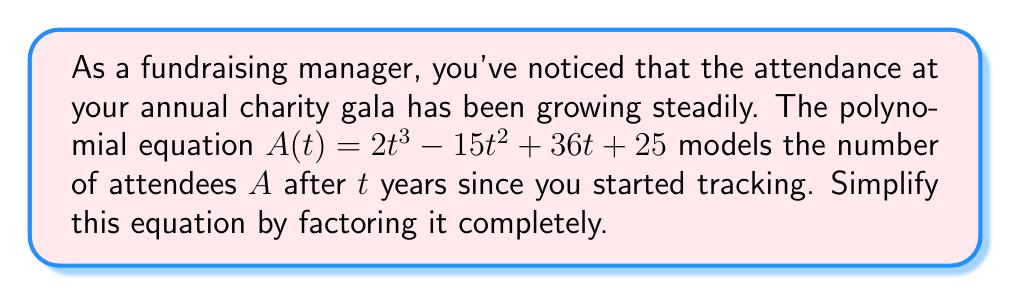Can you answer this question? Let's approach this step-by-step:

1) First, we need to identify if there are any common factors. In this case, there are no common factors for all terms.

2) Next, we'll check if this is a perfect cubic equation. It's not, so we'll proceed with factoring.

3) We can use the rational root theorem to find potential roots. The factors of the constant term (25) are: ±1, ±5, ±25.

4) Testing these values, we find that -1 is a root of the equation.

5) We can factor out $(t+1)$:

   $A(t) = (t+1)(2t^2 - 17t + 25)$

6) Now we need to factor the quadratic term $2t^2 - 17t + 25$. We can use the quadratic formula or factoring by grouping.

7) Using the quadratic formula:
   $t = \frac{17 \pm \sqrt{17^2 - 4(2)(25)}}{2(2)} = \frac{17 \pm \sqrt{289 - 200}}{4} = \frac{17 \pm \sqrt{89}}{4}$

8) This doesn't give us nice rational roots, so let's try factoring by grouping:

   $2t^2 - 17t + 25 = (2t - 5)(t - 5)$

9) Therefore, our final factored equation is:

   $A(t) = (t+1)(2t-5)(t-5)$

This factored form represents the simplified polynomial equation modeling event attendance growth.
Answer: $A(t) = (t+1)(2t-5)(t-5)$ 